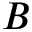Convert formula to latex. <formula><loc_0><loc_0><loc_500><loc_500>B</formula> 